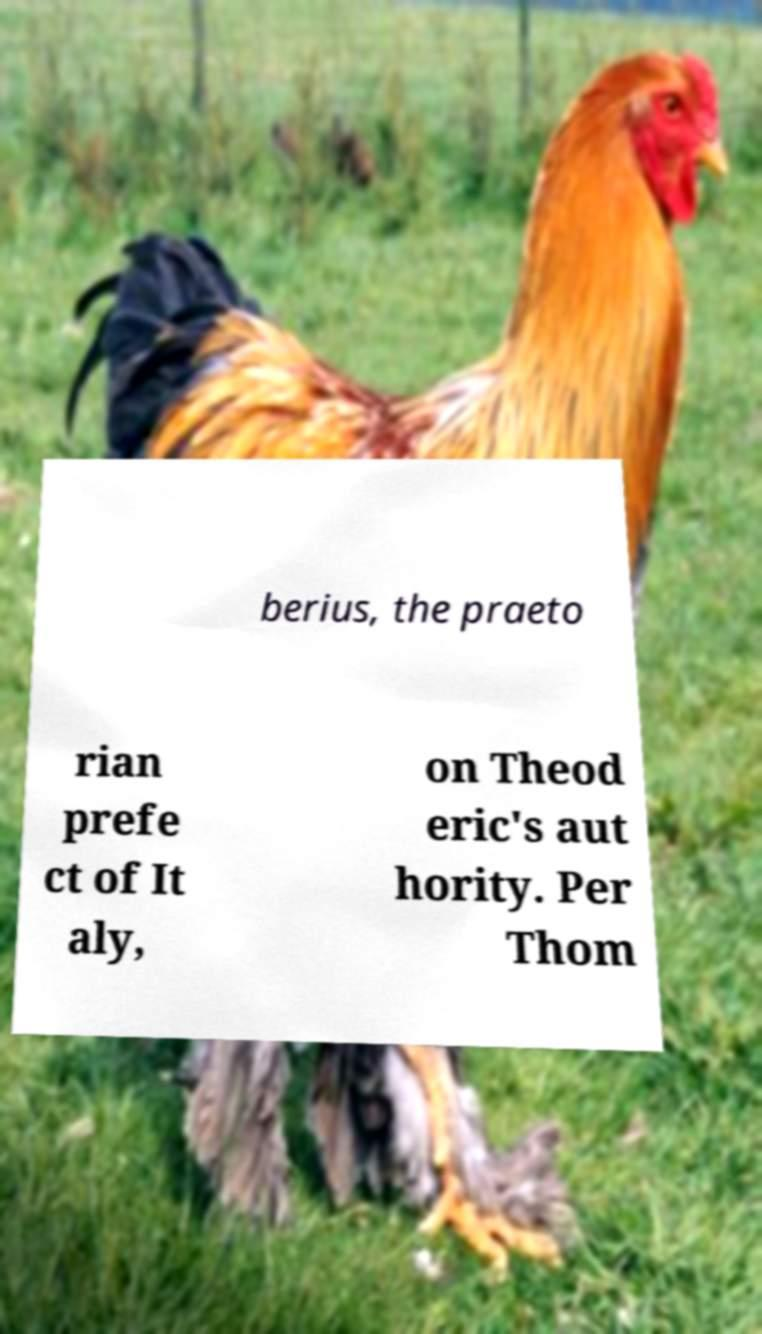For documentation purposes, I need the text within this image transcribed. Could you provide that? berius, the praeto rian prefe ct of It aly, on Theod eric's aut hority. Per Thom 